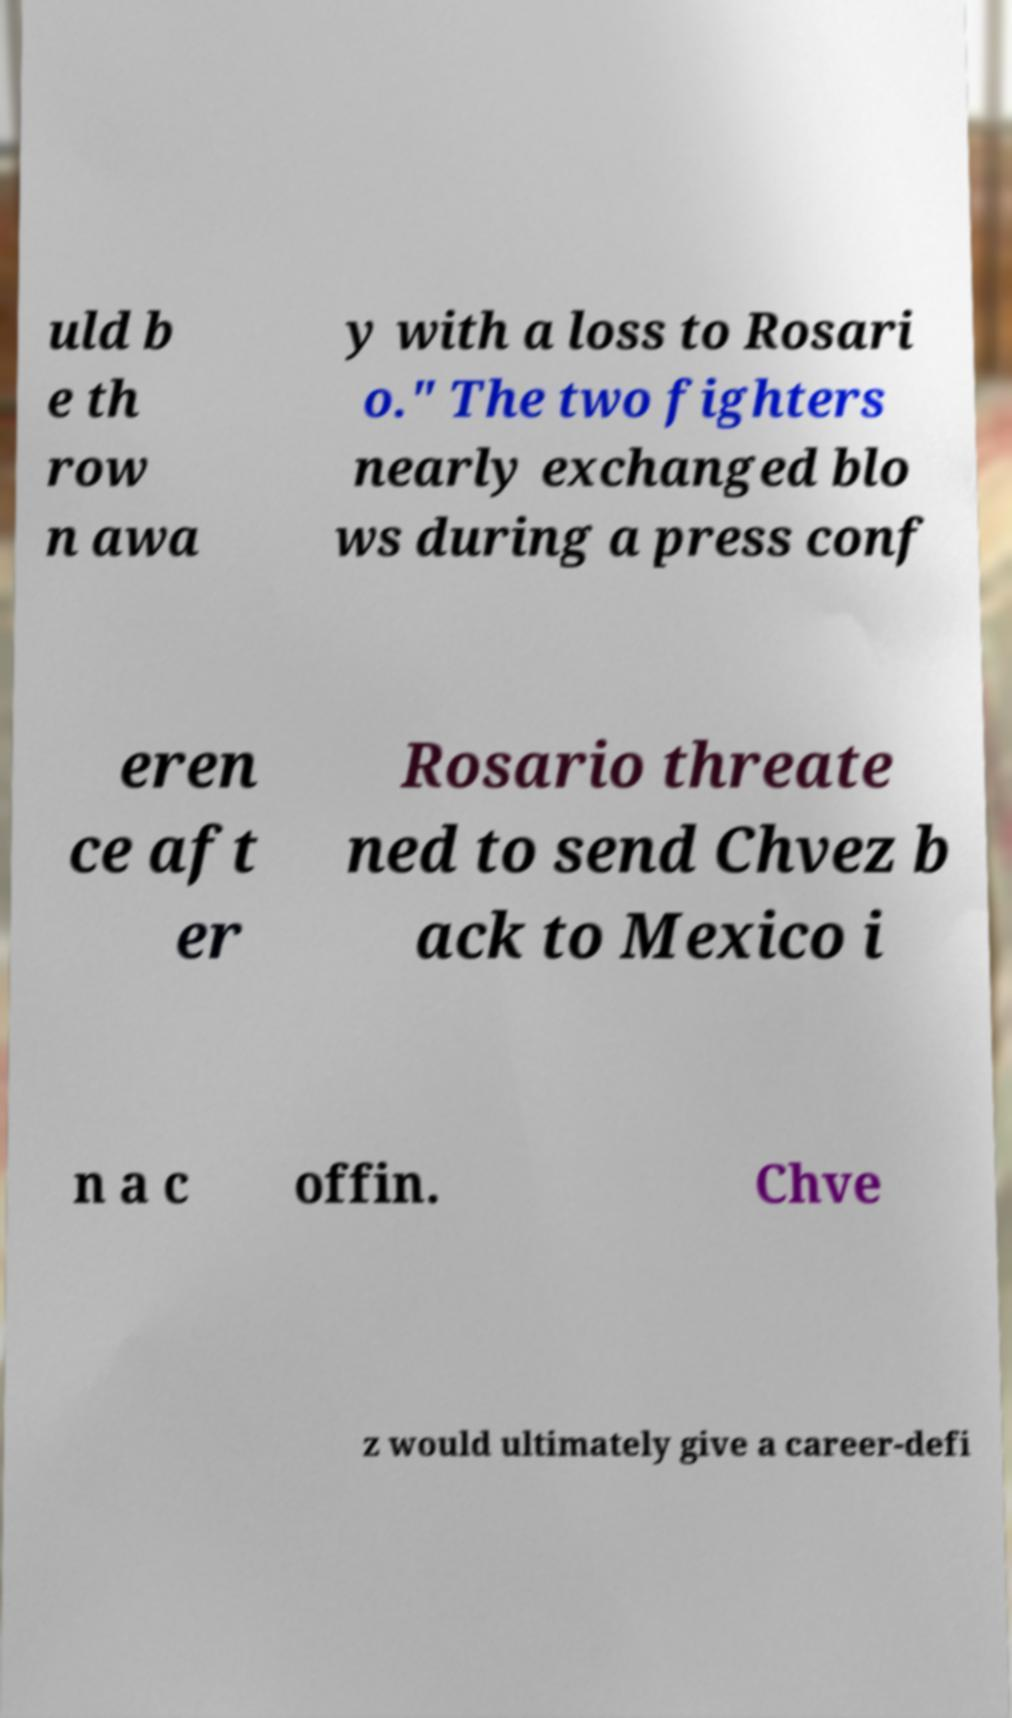I need the written content from this picture converted into text. Can you do that? uld b e th row n awa y with a loss to Rosari o." The two fighters nearly exchanged blo ws during a press conf eren ce aft er Rosario threate ned to send Chvez b ack to Mexico i n a c offin. Chve z would ultimately give a career-defi 